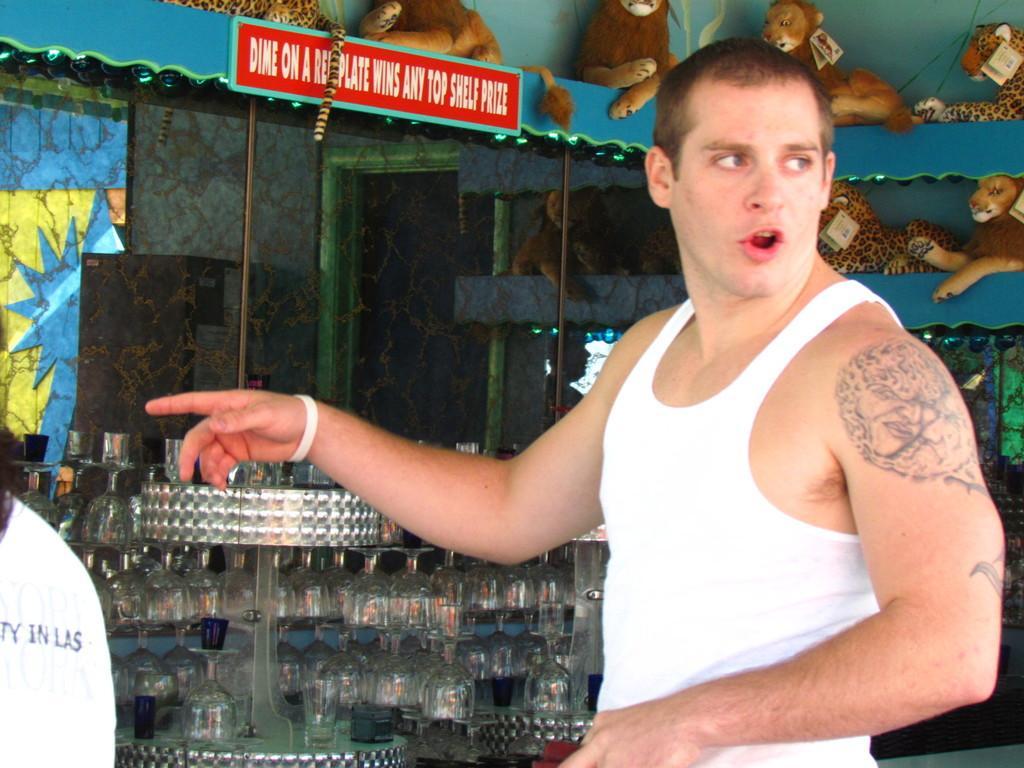How would you summarize this image in a sentence or two? In the foreground of this image, there is a man on the right. Behind him, there are few toys in the shelf, a glass wall and few glasses on the stands and there is some text on the white color object on the left. 